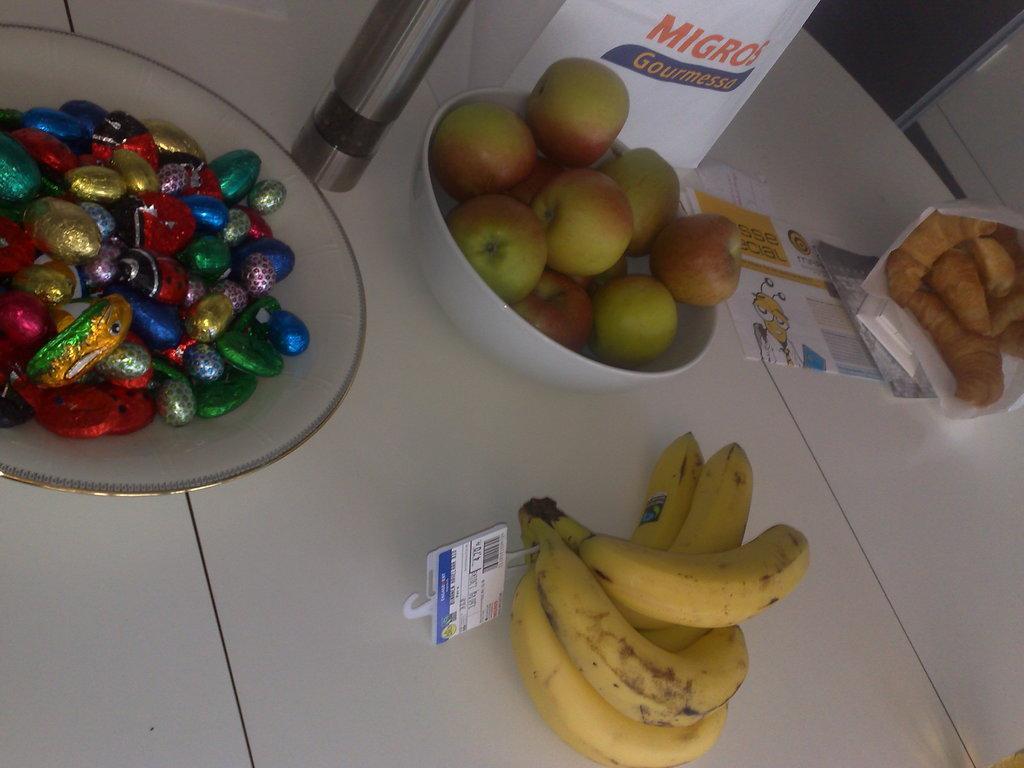Could you give a brief overview of what you see in this image? This picture is clicked inside. In the foreground we can see a bowl containing apples and a bowl containing chocolates and we can see the bunch of bananas, some food items and some papers are placed on the top of the white color table. In the background there are some objects. 